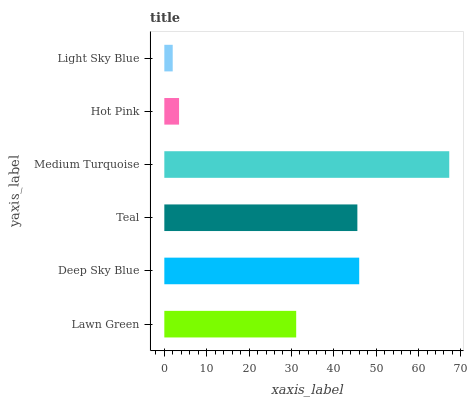Is Light Sky Blue the minimum?
Answer yes or no. Yes. Is Medium Turquoise the maximum?
Answer yes or no. Yes. Is Deep Sky Blue the minimum?
Answer yes or no. No. Is Deep Sky Blue the maximum?
Answer yes or no. No. Is Deep Sky Blue greater than Lawn Green?
Answer yes or no. Yes. Is Lawn Green less than Deep Sky Blue?
Answer yes or no. Yes. Is Lawn Green greater than Deep Sky Blue?
Answer yes or no. No. Is Deep Sky Blue less than Lawn Green?
Answer yes or no. No. Is Teal the high median?
Answer yes or no. Yes. Is Lawn Green the low median?
Answer yes or no. Yes. Is Hot Pink the high median?
Answer yes or no. No. Is Teal the low median?
Answer yes or no. No. 